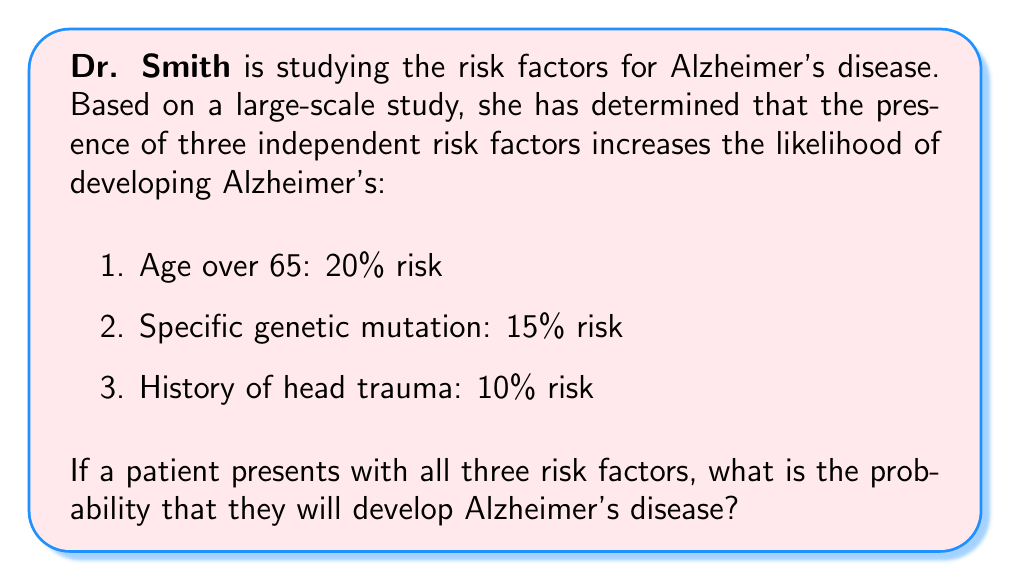Teach me how to tackle this problem. To solve this problem, we need to approach it from the perspective of probability theory, specifically using the concept of independent events.

1. First, let's consider the probability of not developing Alzheimer's for each risk factor:

   Age over 65: $P(\text{not developing | age}) = 1 - 0.20 = 0.80$
   Genetic mutation: $P(\text{not developing | gene}) = 1 - 0.15 = 0.85$
   Head trauma history: $P(\text{not developing | trauma}) = 1 - 0.10 = 0.90$

2. Since the risk factors are independent, we can multiply these probabilities to find the probability of not developing Alzheimer's with all three risk factors present:

   $P(\text{not developing}) = 0.80 \times 0.85 \times 0.90 = 0.612$

3. Therefore, the probability of developing Alzheimer's is the complement of this probability:

   $P(\text{developing}) = 1 - P(\text{not developing}) = 1 - 0.612 = 0.388$

4. Converting to a percentage:

   $0.388 \times 100\% = 38.8\%$

This approach uses the multiplication rule for independent events and the complement rule of probability. It's important to note that in real-world scenarios, risk factors for neurodegenerative diseases may not always be strictly independent, and more complex models might be necessary for accurate risk assessment.
Answer: The probability that a patient with all three risk factors will develop Alzheimer's disease is 38.8%. 